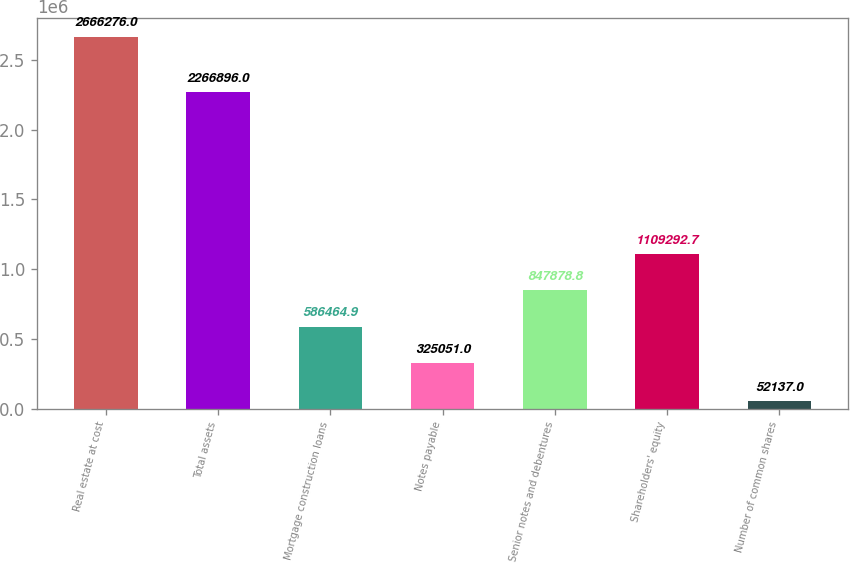Convert chart. <chart><loc_0><loc_0><loc_500><loc_500><bar_chart><fcel>Real estate at cost<fcel>Total assets<fcel>Mortgage construction loans<fcel>Notes payable<fcel>Senior notes and debentures<fcel>Shareholders' equity<fcel>Number of common shares<nl><fcel>2.66628e+06<fcel>2.2669e+06<fcel>586465<fcel>325051<fcel>847879<fcel>1.10929e+06<fcel>52137<nl></chart> 